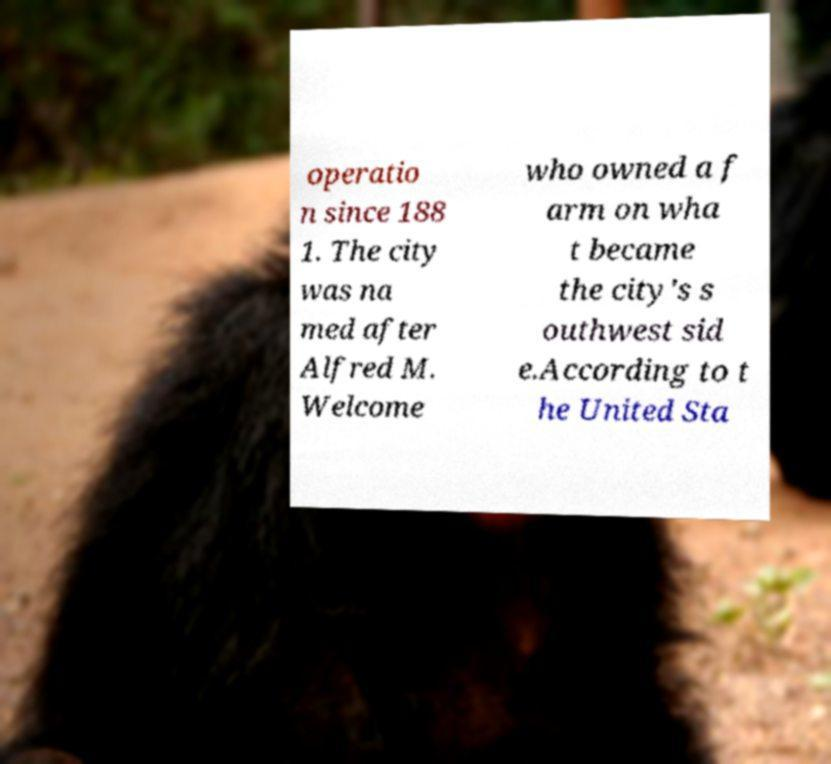What messages or text are displayed in this image? I need them in a readable, typed format. operatio n since 188 1. The city was na med after Alfred M. Welcome who owned a f arm on wha t became the city's s outhwest sid e.According to t he United Sta 